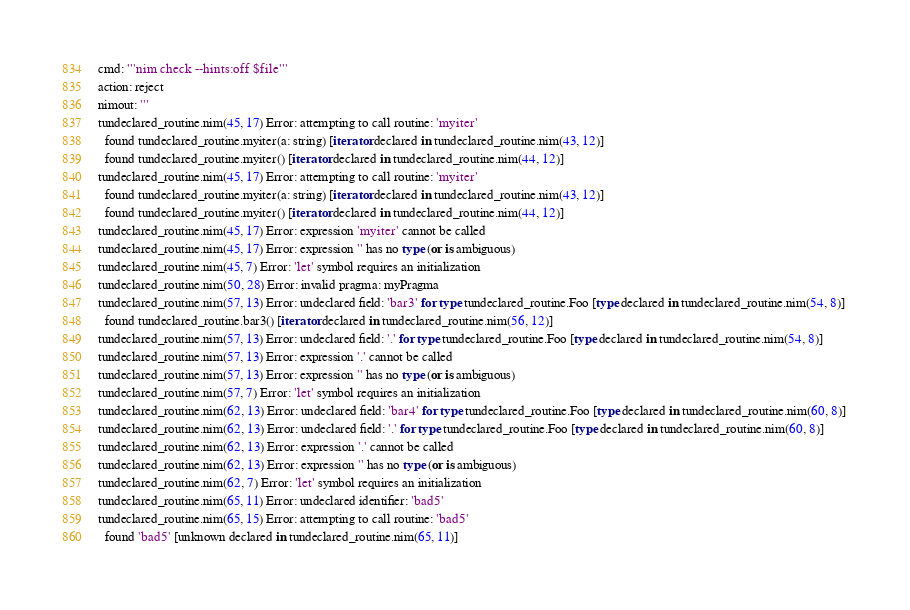<code> <loc_0><loc_0><loc_500><loc_500><_Nim_>cmd: '''nim check --hints:off $file'''
action: reject
nimout: '''
tundeclared_routine.nim(45, 17) Error: attempting to call routine: 'myiter'
  found tundeclared_routine.myiter(a: string) [iterator declared in tundeclared_routine.nim(43, 12)]
  found tundeclared_routine.myiter() [iterator declared in tundeclared_routine.nim(44, 12)]
tundeclared_routine.nim(45, 17) Error: attempting to call routine: 'myiter'
  found tundeclared_routine.myiter(a: string) [iterator declared in tundeclared_routine.nim(43, 12)]
  found tundeclared_routine.myiter() [iterator declared in tundeclared_routine.nim(44, 12)]
tundeclared_routine.nim(45, 17) Error: expression 'myiter' cannot be called
tundeclared_routine.nim(45, 17) Error: expression '' has no type (or is ambiguous)
tundeclared_routine.nim(45, 7) Error: 'let' symbol requires an initialization
tundeclared_routine.nim(50, 28) Error: invalid pragma: myPragma
tundeclared_routine.nim(57, 13) Error: undeclared field: 'bar3' for type tundeclared_routine.Foo [type declared in tundeclared_routine.nim(54, 8)] 
  found tundeclared_routine.bar3() [iterator declared in tundeclared_routine.nim(56, 12)]
tundeclared_routine.nim(57, 13) Error: undeclared field: '.' for type tundeclared_routine.Foo [type declared in tundeclared_routine.nim(54, 8)]
tundeclared_routine.nim(57, 13) Error: expression '.' cannot be called
tundeclared_routine.nim(57, 13) Error: expression '' has no type (or is ambiguous)
tundeclared_routine.nim(57, 7) Error: 'let' symbol requires an initialization
tundeclared_routine.nim(62, 13) Error: undeclared field: 'bar4' for type tundeclared_routine.Foo [type declared in tundeclared_routine.nim(60, 8)]
tundeclared_routine.nim(62, 13) Error: undeclared field: '.' for type tundeclared_routine.Foo [type declared in tundeclared_routine.nim(60, 8)]
tundeclared_routine.nim(62, 13) Error: expression '.' cannot be called
tundeclared_routine.nim(62, 13) Error: expression '' has no type (or is ambiguous)
tundeclared_routine.nim(62, 7) Error: 'let' symbol requires an initialization
tundeclared_routine.nim(65, 11) Error: undeclared identifier: 'bad5'
tundeclared_routine.nim(65, 15) Error: attempting to call routine: 'bad5'
  found 'bad5' [unknown declared in tundeclared_routine.nim(65, 11)]</code> 